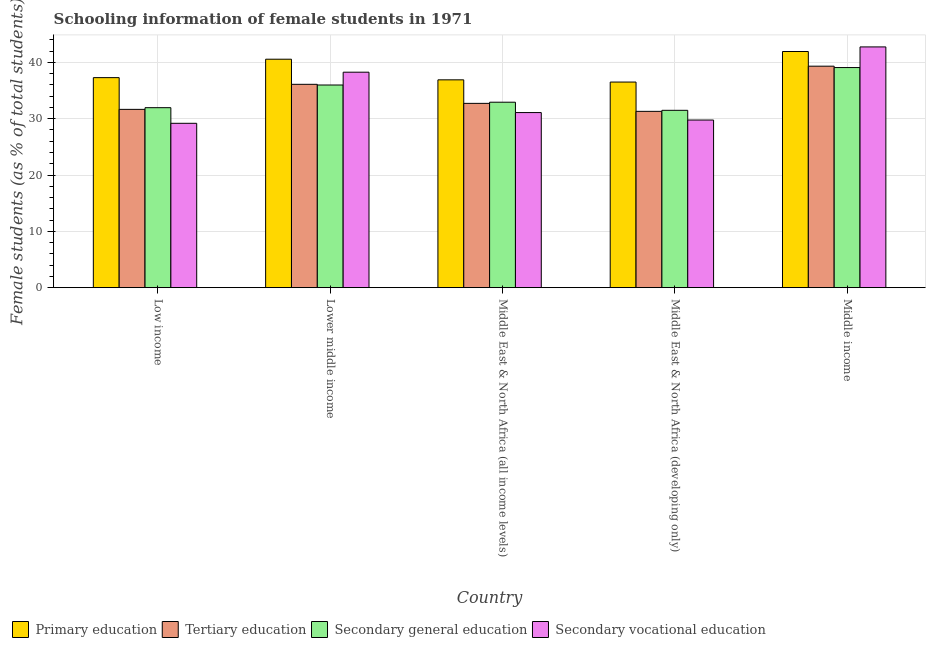How many different coloured bars are there?
Provide a succinct answer. 4. How many groups of bars are there?
Your answer should be compact. 5. How many bars are there on the 1st tick from the left?
Offer a very short reply. 4. What is the label of the 4th group of bars from the left?
Your answer should be compact. Middle East & North Africa (developing only). In how many cases, is the number of bars for a given country not equal to the number of legend labels?
Provide a succinct answer. 0. What is the percentage of female students in primary education in Low income?
Ensure brevity in your answer.  37.3. Across all countries, what is the maximum percentage of female students in tertiary education?
Your response must be concise. 39.33. Across all countries, what is the minimum percentage of female students in primary education?
Keep it short and to the point. 36.51. In which country was the percentage of female students in tertiary education minimum?
Ensure brevity in your answer.  Middle East & North Africa (developing only). What is the total percentage of female students in secondary vocational education in the graph?
Your answer should be very brief. 171.05. What is the difference between the percentage of female students in secondary vocational education in Low income and that in Middle East & North Africa (developing only)?
Provide a short and direct response. -0.58. What is the difference between the percentage of female students in tertiary education in Low income and the percentage of female students in secondary education in Middle income?
Your response must be concise. -7.42. What is the average percentage of female students in secondary education per country?
Provide a short and direct response. 34.29. What is the difference between the percentage of female students in secondary vocational education and percentage of female students in primary education in Lower middle income?
Keep it short and to the point. -2.31. In how many countries, is the percentage of female students in primary education greater than 40 %?
Provide a short and direct response. 2. What is the ratio of the percentage of female students in primary education in Lower middle income to that in Middle East & North Africa (developing only)?
Keep it short and to the point. 1.11. What is the difference between the highest and the second highest percentage of female students in secondary vocational education?
Make the answer very short. 4.49. What is the difference between the highest and the lowest percentage of female students in tertiary education?
Offer a very short reply. 8.02. In how many countries, is the percentage of female students in primary education greater than the average percentage of female students in primary education taken over all countries?
Make the answer very short. 2. Is the sum of the percentage of female students in primary education in Low income and Middle East & North Africa (all income levels) greater than the maximum percentage of female students in secondary education across all countries?
Your answer should be compact. Yes. What does the 4th bar from the left in Middle East & North Africa (developing only) represents?
Your answer should be very brief. Secondary vocational education. What does the 2nd bar from the right in Middle East & North Africa (developing only) represents?
Give a very brief answer. Secondary general education. Are the values on the major ticks of Y-axis written in scientific E-notation?
Your response must be concise. No. Does the graph contain any zero values?
Provide a short and direct response. No. Does the graph contain grids?
Offer a very short reply. Yes. Where does the legend appear in the graph?
Keep it short and to the point. Bottom left. How many legend labels are there?
Give a very brief answer. 4. What is the title of the graph?
Make the answer very short. Schooling information of female students in 1971. Does "Financial sector" appear as one of the legend labels in the graph?
Keep it short and to the point. No. What is the label or title of the X-axis?
Provide a succinct answer. Country. What is the label or title of the Y-axis?
Make the answer very short. Female students (as % of total students). What is the Female students (as % of total students) of Primary education in Low income?
Offer a very short reply. 37.3. What is the Female students (as % of total students) of Tertiary education in Low income?
Provide a succinct answer. 31.66. What is the Female students (as % of total students) of Secondary general education in Low income?
Keep it short and to the point. 31.96. What is the Female students (as % of total students) in Secondary vocational education in Low income?
Keep it short and to the point. 29.18. What is the Female students (as % of total students) in Primary education in Lower middle income?
Offer a very short reply. 40.57. What is the Female students (as % of total students) of Tertiary education in Lower middle income?
Provide a short and direct response. 36.11. What is the Female students (as % of total students) of Secondary general education in Lower middle income?
Your answer should be compact. 35.99. What is the Female students (as % of total students) in Secondary vocational education in Lower middle income?
Your answer should be compact. 38.26. What is the Female students (as % of total students) of Primary education in Middle East & North Africa (all income levels)?
Your response must be concise. 36.9. What is the Female students (as % of total students) of Tertiary education in Middle East & North Africa (all income levels)?
Keep it short and to the point. 32.73. What is the Female students (as % of total students) in Secondary general education in Middle East & North Africa (all income levels)?
Provide a succinct answer. 32.93. What is the Female students (as % of total students) of Secondary vocational education in Middle East & North Africa (all income levels)?
Ensure brevity in your answer.  31.09. What is the Female students (as % of total students) of Primary education in Middle East & North Africa (developing only)?
Provide a succinct answer. 36.51. What is the Female students (as % of total students) of Tertiary education in Middle East & North Africa (developing only)?
Provide a succinct answer. 31.31. What is the Female students (as % of total students) of Secondary general education in Middle East & North Africa (developing only)?
Your response must be concise. 31.49. What is the Female students (as % of total students) of Secondary vocational education in Middle East & North Africa (developing only)?
Offer a terse response. 29.76. What is the Female students (as % of total students) of Primary education in Middle income?
Make the answer very short. 41.93. What is the Female students (as % of total students) of Tertiary education in Middle income?
Keep it short and to the point. 39.33. What is the Female students (as % of total students) of Secondary general education in Middle income?
Your response must be concise. 39.08. What is the Female students (as % of total students) of Secondary vocational education in Middle income?
Make the answer very short. 42.75. Across all countries, what is the maximum Female students (as % of total students) in Primary education?
Ensure brevity in your answer.  41.93. Across all countries, what is the maximum Female students (as % of total students) of Tertiary education?
Provide a succinct answer. 39.33. Across all countries, what is the maximum Female students (as % of total students) of Secondary general education?
Make the answer very short. 39.08. Across all countries, what is the maximum Female students (as % of total students) in Secondary vocational education?
Keep it short and to the point. 42.75. Across all countries, what is the minimum Female students (as % of total students) of Primary education?
Your response must be concise. 36.51. Across all countries, what is the minimum Female students (as % of total students) of Tertiary education?
Provide a short and direct response. 31.31. Across all countries, what is the minimum Female students (as % of total students) of Secondary general education?
Make the answer very short. 31.49. Across all countries, what is the minimum Female students (as % of total students) in Secondary vocational education?
Offer a very short reply. 29.18. What is the total Female students (as % of total students) of Primary education in the graph?
Offer a terse response. 193.21. What is the total Female students (as % of total students) of Tertiary education in the graph?
Ensure brevity in your answer.  171.13. What is the total Female students (as % of total students) in Secondary general education in the graph?
Offer a very short reply. 171.46. What is the total Female students (as % of total students) in Secondary vocational education in the graph?
Give a very brief answer. 171.05. What is the difference between the Female students (as % of total students) in Primary education in Low income and that in Lower middle income?
Keep it short and to the point. -3.27. What is the difference between the Female students (as % of total students) in Tertiary education in Low income and that in Lower middle income?
Offer a very short reply. -4.45. What is the difference between the Female students (as % of total students) in Secondary general education in Low income and that in Lower middle income?
Your answer should be compact. -4.03. What is the difference between the Female students (as % of total students) of Secondary vocational education in Low income and that in Lower middle income?
Your answer should be very brief. -9.08. What is the difference between the Female students (as % of total students) of Primary education in Low income and that in Middle East & North Africa (all income levels)?
Ensure brevity in your answer.  0.39. What is the difference between the Female students (as % of total students) of Tertiary education in Low income and that in Middle East & North Africa (all income levels)?
Provide a short and direct response. -1.07. What is the difference between the Female students (as % of total students) of Secondary general education in Low income and that in Middle East & North Africa (all income levels)?
Keep it short and to the point. -0.97. What is the difference between the Female students (as % of total students) of Secondary vocational education in Low income and that in Middle East & North Africa (all income levels)?
Ensure brevity in your answer.  -1.91. What is the difference between the Female students (as % of total students) of Primary education in Low income and that in Middle East & North Africa (developing only)?
Provide a succinct answer. 0.78. What is the difference between the Female students (as % of total students) in Tertiary education in Low income and that in Middle East & North Africa (developing only)?
Keep it short and to the point. 0.35. What is the difference between the Female students (as % of total students) of Secondary general education in Low income and that in Middle East & North Africa (developing only)?
Make the answer very short. 0.47. What is the difference between the Female students (as % of total students) of Secondary vocational education in Low income and that in Middle East & North Africa (developing only)?
Your response must be concise. -0.58. What is the difference between the Female students (as % of total students) of Primary education in Low income and that in Middle income?
Your answer should be very brief. -4.64. What is the difference between the Female students (as % of total students) in Tertiary education in Low income and that in Middle income?
Your answer should be compact. -7.67. What is the difference between the Female students (as % of total students) of Secondary general education in Low income and that in Middle income?
Your answer should be compact. -7.12. What is the difference between the Female students (as % of total students) in Secondary vocational education in Low income and that in Middle income?
Your answer should be compact. -13.57. What is the difference between the Female students (as % of total students) in Primary education in Lower middle income and that in Middle East & North Africa (all income levels)?
Provide a short and direct response. 3.66. What is the difference between the Female students (as % of total students) of Tertiary education in Lower middle income and that in Middle East & North Africa (all income levels)?
Provide a succinct answer. 3.38. What is the difference between the Female students (as % of total students) of Secondary general education in Lower middle income and that in Middle East & North Africa (all income levels)?
Ensure brevity in your answer.  3.05. What is the difference between the Female students (as % of total students) of Secondary vocational education in Lower middle income and that in Middle East & North Africa (all income levels)?
Keep it short and to the point. 7.17. What is the difference between the Female students (as % of total students) in Primary education in Lower middle income and that in Middle East & North Africa (developing only)?
Provide a short and direct response. 4.06. What is the difference between the Female students (as % of total students) of Tertiary education in Lower middle income and that in Middle East & North Africa (developing only)?
Give a very brief answer. 4.8. What is the difference between the Female students (as % of total students) of Secondary general education in Lower middle income and that in Middle East & North Africa (developing only)?
Make the answer very short. 4.5. What is the difference between the Female students (as % of total students) of Secondary vocational education in Lower middle income and that in Middle East & North Africa (developing only)?
Provide a succinct answer. 8.49. What is the difference between the Female students (as % of total students) in Primary education in Lower middle income and that in Middle income?
Give a very brief answer. -1.37. What is the difference between the Female students (as % of total students) of Tertiary education in Lower middle income and that in Middle income?
Your answer should be very brief. -3.22. What is the difference between the Female students (as % of total students) of Secondary general education in Lower middle income and that in Middle income?
Provide a short and direct response. -3.1. What is the difference between the Female students (as % of total students) of Secondary vocational education in Lower middle income and that in Middle income?
Offer a very short reply. -4.49. What is the difference between the Female students (as % of total students) of Primary education in Middle East & North Africa (all income levels) and that in Middle East & North Africa (developing only)?
Give a very brief answer. 0.39. What is the difference between the Female students (as % of total students) of Tertiary education in Middle East & North Africa (all income levels) and that in Middle East & North Africa (developing only)?
Ensure brevity in your answer.  1.42. What is the difference between the Female students (as % of total students) in Secondary general education in Middle East & North Africa (all income levels) and that in Middle East & North Africa (developing only)?
Keep it short and to the point. 1.44. What is the difference between the Female students (as % of total students) in Secondary vocational education in Middle East & North Africa (all income levels) and that in Middle East & North Africa (developing only)?
Give a very brief answer. 1.33. What is the difference between the Female students (as % of total students) of Primary education in Middle East & North Africa (all income levels) and that in Middle income?
Your response must be concise. -5.03. What is the difference between the Female students (as % of total students) of Tertiary education in Middle East & North Africa (all income levels) and that in Middle income?
Provide a short and direct response. -6.6. What is the difference between the Female students (as % of total students) of Secondary general education in Middle East & North Africa (all income levels) and that in Middle income?
Your answer should be very brief. -6.15. What is the difference between the Female students (as % of total students) in Secondary vocational education in Middle East & North Africa (all income levels) and that in Middle income?
Ensure brevity in your answer.  -11.66. What is the difference between the Female students (as % of total students) of Primary education in Middle East & North Africa (developing only) and that in Middle income?
Provide a short and direct response. -5.42. What is the difference between the Female students (as % of total students) in Tertiary education in Middle East & North Africa (developing only) and that in Middle income?
Your response must be concise. -8.02. What is the difference between the Female students (as % of total students) of Secondary general education in Middle East & North Africa (developing only) and that in Middle income?
Give a very brief answer. -7.59. What is the difference between the Female students (as % of total students) in Secondary vocational education in Middle East & North Africa (developing only) and that in Middle income?
Your response must be concise. -12.99. What is the difference between the Female students (as % of total students) in Primary education in Low income and the Female students (as % of total students) in Tertiary education in Lower middle income?
Your answer should be very brief. 1.19. What is the difference between the Female students (as % of total students) of Primary education in Low income and the Female students (as % of total students) of Secondary general education in Lower middle income?
Your answer should be compact. 1.31. What is the difference between the Female students (as % of total students) in Primary education in Low income and the Female students (as % of total students) in Secondary vocational education in Lower middle income?
Give a very brief answer. -0.96. What is the difference between the Female students (as % of total students) of Tertiary education in Low income and the Female students (as % of total students) of Secondary general education in Lower middle income?
Offer a terse response. -4.33. What is the difference between the Female students (as % of total students) of Tertiary education in Low income and the Female students (as % of total students) of Secondary vocational education in Lower middle income?
Keep it short and to the point. -6.6. What is the difference between the Female students (as % of total students) of Secondary general education in Low income and the Female students (as % of total students) of Secondary vocational education in Lower middle income?
Your answer should be compact. -6.3. What is the difference between the Female students (as % of total students) of Primary education in Low income and the Female students (as % of total students) of Tertiary education in Middle East & North Africa (all income levels)?
Give a very brief answer. 4.57. What is the difference between the Female students (as % of total students) in Primary education in Low income and the Female students (as % of total students) in Secondary general education in Middle East & North Africa (all income levels)?
Ensure brevity in your answer.  4.36. What is the difference between the Female students (as % of total students) of Primary education in Low income and the Female students (as % of total students) of Secondary vocational education in Middle East & North Africa (all income levels)?
Provide a succinct answer. 6.2. What is the difference between the Female students (as % of total students) in Tertiary education in Low income and the Female students (as % of total students) in Secondary general education in Middle East & North Africa (all income levels)?
Offer a very short reply. -1.27. What is the difference between the Female students (as % of total students) of Tertiary education in Low income and the Female students (as % of total students) of Secondary vocational education in Middle East & North Africa (all income levels)?
Provide a succinct answer. 0.57. What is the difference between the Female students (as % of total students) in Secondary general education in Low income and the Female students (as % of total students) in Secondary vocational education in Middle East & North Africa (all income levels)?
Offer a terse response. 0.87. What is the difference between the Female students (as % of total students) of Primary education in Low income and the Female students (as % of total students) of Tertiary education in Middle East & North Africa (developing only)?
Your response must be concise. 5.99. What is the difference between the Female students (as % of total students) in Primary education in Low income and the Female students (as % of total students) in Secondary general education in Middle East & North Africa (developing only)?
Keep it short and to the point. 5.8. What is the difference between the Female students (as % of total students) of Primary education in Low income and the Female students (as % of total students) of Secondary vocational education in Middle East & North Africa (developing only)?
Your answer should be very brief. 7.53. What is the difference between the Female students (as % of total students) of Tertiary education in Low income and the Female students (as % of total students) of Secondary general education in Middle East & North Africa (developing only)?
Make the answer very short. 0.17. What is the difference between the Female students (as % of total students) in Tertiary education in Low income and the Female students (as % of total students) in Secondary vocational education in Middle East & North Africa (developing only)?
Offer a very short reply. 1.9. What is the difference between the Female students (as % of total students) in Secondary general education in Low income and the Female students (as % of total students) in Secondary vocational education in Middle East & North Africa (developing only)?
Your answer should be compact. 2.2. What is the difference between the Female students (as % of total students) in Primary education in Low income and the Female students (as % of total students) in Tertiary education in Middle income?
Offer a very short reply. -2.03. What is the difference between the Female students (as % of total students) of Primary education in Low income and the Female students (as % of total students) of Secondary general education in Middle income?
Your response must be concise. -1.79. What is the difference between the Female students (as % of total students) of Primary education in Low income and the Female students (as % of total students) of Secondary vocational education in Middle income?
Offer a very short reply. -5.45. What is the difference between the Female students (as % of total students) in Tertiary education in Low income and the Female students (as % of total students) in Secondary general education in Middle income?
Your answer should be compact. -7.42. What is the difference between the Female students (as % of total students) of Tertiary education in Low income and the Female students (as % of total students) of Secondary vocational education in Middle income?
Provide a short and direct response. -11.09. What is the difference between the Female students (as % of total students) in Secondary general education in Low income and the Female students (as % of total students) in Secondary vocational education in Middle income?
Provide a short and direct response. -10.79. What is the difference between the Female students (as % of total students) of Primary education in Lower middle income and the Female students (as % of total students) of Tertiary education in Middle East & North Africa (all income levels)?
Your answer should be compact. 7.84. What is the difference between the Female students (as % of total students) in Primary education in Lower middle income and the Female students (as % of total students) in Secondary general education in Middle East & North Africa (all income levels)?
Give a very brief answer. 7.63. What is the difference between the Female students (as % of total students) in Primary education in Lower middle income and the Female students (as % of total students) in Secondary vocational education in Middle East & North Africa (all income levels)?
Ensure brevity in your answer.  9.47. What is the difference between the Female students (as % of total students) in Tertiary education in Lower middle income and the Female students (as % of total students) in Secondary general education in Middle East & North Africa (all income levels)?
Provide a short and direct response. 3.17. What is the difference between the Female students (as % of total students) of Tertiary education in Lower middle income and the Female students (as % of total students) of Secondary vocational education in Middle East & North Africa (all income levels)?
Ensure brevity in your answer.  5.01. What is the difference between the Female students (as % of total students) in Secondary general education in Lower middle income and the Female students (as % of total students) in Secondary vocational education in Middle East & North Africa (all income levels)?
Ensure brevity in your answer.  4.89. What is the difference between the Female students (as % of total students) of Primary education in Lower middle income and the Female students (as % of total students) of Tertiary education in Middle East & North Africa (developing only)?
Provide a short and direct response. 9.26. What is the difference between the Female students (as % of total students) of Primary education in Lower middle income and the Female students (as % of total students) of Secondary general education in Middle East & North Africa (developing only)?
Provide a short and direct response. 9.07. What is the difference between the Female students (as % of total students) in Primary education in Lower middle income and the Female students (as % of total students) in Secondary vocational education in Middle East & North Africa (developing only)?
Your answer should be compact. 10.8. What is the difference between the Female students (as % of total students) of Tertiary education in Lower middle income and the Female students (as % of total students) of Secondary general education in Middle East & North Africa (developing only)?
Your answer should be compact. 4.61. What is the difference between the Female students (as % of total students) in Tertiary education in Lower middle income and the Female students (as % of total students) in Secondary vocational education in Middle East & North Africa (developing only)?
Your answer should be very brief. 6.34. What is the difference between the Female students (as % of total students) of Secondary general education in Lower middle income and the Female students (as % of total students) of Secondary vocational education in Middle East & North Africa (developing only)?
Your answer should be very brief. 6.22. What is the difference between the Female students (as % of total students) of Primary education in Lower middle income and the Female students (as % of total students) of Tertiary education in Middle income?
Offer a terse response. 1.24. What is the difference between the Female students (as % of total students) of Primary education in Lower middle income and the Female students (as % of total students) of Secondary general education in Middle income?
Offer a terse response. 1.48. What is the difference between the Female students (as % of total students) in Primary education in Lower middle income and the Female students (as % of total students) in Secondary vocational education in Middle income?
Make the answer very short. -2.18. What is the difference between the Female students (as % of total students) of Tertiary education in Lower middle income and the Female students (as % of total students) of Secondary general education in Middle income?
Your answer should be very brief. -2.98. What is the difference between the Female students (as % of total students) in Tertiary education in Lower middle income and the Female students (as % of total students) in Secondary vocational education in Middle income?
Offer a very short reply. -6.64. What is the difference between the Female students (as % of total students) in Secondary general education in Lower middle income and the Female students (as % of total students) in Secondary vocational education in Middle income?
Offer a very short reply. -6.76. What is the difference between the Female students (as % of total students) of Primary education in Middle East & North Africa (all income levels) and the Female students (as % of total students) of Tertiary education in Middle East & North Africa (developing only)?
Ensure brevity in your answer.  5.6. What is the difference between the Female students (as % of total students) of Primary education in Middle East & North Africa (all income levels) and the Female students (as % of total students) of Secondary general education in Middle East & North Africa (developing only)?
Your response must be concise. 5.41. What is the difference between the Female students (as % of total students) in Primary education in Middle East & North Africa (all income levels) and the Female students (as % of total students) in Secondary vocational education in Middle East & North Africa (developing only)?
Keep it short and to the point. 7.14. What is the difference between the Female students (as % of total students) of Tertiary education in Middle East & North Africa (all income levels) and the Female students (as % of total students) of Secondary general education in Middle East & North Africa (developing only)?
Provide a succinct answer. 1.23. What is the difference between the Female students (as % of total students) in Tertiary education in Middle East & North Africa (all income levels) and the Female students (as % of total students) in Secondary vocational education in Middle East & North Africa (developing only)?
Make the answer very short. 2.96. What is the difference between the Female students (as % of total students) of Secondary general education in Middle East & North Africa (all income levels) and the Female students (as % of total students) of Secondary vocational education in Middle East & North Africa (developing only)?
Your response must be concise. 3.17. What is the difference between the Female students (as % of total students) of Primary education in Middle East & North Africa (all income levels) and the Female students (as % of total students) of Tertiary education in Middle income?
Give a very brief answer. -2.42. What is the difference between the Female students (as % of total students) of Primary education in Middle East & North Africa (all income levels) and the Female students (as % of total students) of Secondary general education in Middle income?
Offer a very short reply. -2.18. What is the difference between the Female students (as % of total students) in Primary education in Middle East & North Africa (all income levels) and the Female students (as % of total students) in Secondary vocational education in Middle income?
Make the answer very short. -5.85. What is the difference between the Female students (as % of total students) of Tertiary education in Middle East & North Africa (all income levels) and the Female students (as % of total students) of Secondary general education in Middle income?
Keep it short and to the point. -6.36. What is the difference between the Female students (as % of total students) of Tertiary education in Middle East & North Africa (all income levels) and the Female students (as % of total students) of Secondary vocational education in Middle income?
Provide a succinct answer. -10.02. What is the difference between the Female students (as % of total students) in Secondary general education in Middle East & North Africa (all income levels) and the Female students (as % of total students) in Secondary vocational education in Middle income?
Offer a terse response. -9.82. What is the difference between the Female students (as % of total students) in Primary education in Middle East & North Africa (developing only) and the Female students (as % of total students) in Tertiary education in Middle income?
Your answer should be compact. -2.82. What is the difference between the Female students (as % of total students) of Primary education in Middle East & North Africa (developing only) and the Female students (as % of total students) of Secondary general education in Middle income?
Your answer should be very brief. -2.57. What is the difference between the Female students (as % of total students) in Primary education in Middle East & North Africa (developing only) and the Female students (as % of total students) in Secondary vocational education in Middle income?
Ensure brevity in your answer.  -6.24. What is the difference between the Female students (as % of total students) of Tertiary education in Middle East & North Africa (developing only) and the Female students (as % of total students) of Secondary general education in Middle income?
Ensure brevity in your answer.  -7.78. What is the difference between the Female students (as % of total students) in Tertiary education in Middle East & North Africa (developing only) and the Female students (as % of total students) in Secondary vocational education in Middle income?
Your answer should be very brief. -11.44. What is the difference between the Female students (as % of total students) of Secondary general education in Middle East & North Africa (developing only) and the Female students (as % of total students) of Secondary vocational education in Middle income?
Make the answer very short. -11.26. What is the average Female students (as % of total students) in Primary education per country?
Your answer should be very brief. 38.64. What is the average Female students (as % of total students) in Tertiary education per country?
Offer a terse response. 34.23. What is the average Female students (as % of total students) in Secondary general education per country?
Your response must be concise. 34.29. What is the average Female students (as % of total students) of Secondary vocational education per country?
Keep it short and to the point. 34.21. What is the difference between the Female students (as % of total students) of Primary education and Female students (as % of total students) of Tertiary education in Low income?
Provide a short and direct response. 5.63. What is the difference between the Female students (as % of total students) in Primary education and Female students (as % of total students) in Secondary general education in Low income?
Offer a very short reply. 5.33. What is the difference between the Female students (as % of total students) in Primary education and Female students (as % of total students) in Secondary vocational education in Low income?
Give a very brief answer. 8.11. What is the difference between the Female students (as % of total students) in Tertiary education and Female students (as % of total students) in Secondary general education in Low income?
Give a very brief answer. -0.3. What is the difference between the Female students (as % of total students) of Tertiary education and Female students (as % of total students) of Secondary vocational education in Low income?
Your response must be concise. 2.48. What is the difference between the Female students (as % of total students) in Secondary general education and Female students (as % of total students) in Secondary vocational education in Low income?
Your answer should be very brief. 2.78. What is the difference between the Female students (as % of total students) of Primary education and Female students (as % of total students) of Tertiary education in Lower middle income?
Ensure brevity in your answer.  4.46. What is the difference between the Female students (as % of total students) of Primary education and Female students (as % of total students) of Secondary general education in Lower middle income?
Provide a short and direct response. 4.58. What is the difference between the Female students (as % of total students) in Primary education and Female students (as % of total students) in Secondary vocational education in Lower middle income?
Give a very brief answer. 2.31. What is the difference between the Female students (as % of total students) of Tertiary education and Female students (as % of total students) of Secondary general education in Lower middle income?
Keep it short and to the point. 0.12. What is the difference between the Female students (as % of total students) of Tertiary education and Female students (as % of total students) of Secondary vocational education in Lower middle income?
Offer a terse response. -2.15. What is the difference between the Female students (as % of total students) of Secondary general education and Female students (as % of total students) of Secondary vocational education in Lower middle income?
Your answer should be compact. -2.27. What is the difference between the Female students (as % of total students) of Primary education and Female students (as % of total students) of Tertiary education in Middle East & North Africa (all income levels)?
Keep it short and to the point. 4.18. What is the difference between the Female students (as % of total students) in Primary education and Female students (as % of total students) in Secondary general education in Middle East & North Africa (all income levels)?
Provide a short and direct response. 3.97. What is the difference between the Female students (as % of total students) in Primary education and Female students (as % of total students) in Secondary vocational education in Middle East & North Africa (all income levels)?
Provide a short and direct response. 5.81. What is the difference between the Female students (as % of total students) in Tertiary education and Female students (as % of total students) in Secondary general education in Middle East & North Africa (all income levels)?
Ensure brevity in your answer.  -0.21. What is the difference between the Female students (as % of total students) in Tertiary education and Female students (as % of total students) in Secondary vocational education in Middle East & North Africa (all income levels)?
Give a very brief answer. 1.63. What is the difference between the Female students (as % of total students) of Secondary general education and Female students (as % of total students) of Secondary vocational education in Middle East & North Africa (all income levels)?
Your response must be concise. 1.84. What is the difference between the Female students (as % of total students) in Primary education and Female students (as % of total students) in Tertiary education in Middle East & North Africa (developing only)?
Your answer should be compact. 5.2. What is the difference between the Female students (as % of total students) in Primary education and Female students (as % of total students) in Secondary general education in Middle East & North Africa (developing only)?
Your answer should be compact. 5.02. What is the difference between the Female students (as % of total students) of Primary education and Female students (as % of total students) of Secondary vocational education in Middle East & North Africa (developing only)?
Offer a very short reply. 6.75. What is the difference between the Female students (as % of total students) of Tertiary education and Female students (as % of total students) of Secondary general education in Middle East & North Africa (developing only)?
Offer a very short reply. -0.18. What is the difference between the Female students (as % of total students) of Tertiary education and Female students (as % of total students) of Secondary vocational education in Middle East & North Africa (developing only)?
Your response must be concise. 1.54. What is the difference between the Female students (as % of total students) in Secondary general education and Female students (as % of total students) in Secondary vocational education in Middle East & North Africa (developing only)?
Make the answer very short. 1.73. What is the difference between the Female students (as % of total students) in Primary education and Female students (as % of total students) in Tertiary education in Middle income?
Provide a succinct answer. 2.61. What is the difference between the Female students (as % of total students) in Primary education and Female students (as % of total students) in Secondary general education in Middle income?
Your answer should be compact. 2.85. What is the difference between the Female students (as % of total students) of Primary education and Female students (as % of total students) of Secondary vocational education in Middle income?
Provide a short and direct response. -0.82. What is the difference between the Female students (as % of total students) in Tertiary education and Female students (as % of total students) in Secondary general education in Middle income?
Your answer should be very brief. 0.24. What is the difference between the Female students (as % of total students) of Tertiary education and Female students (as % of total students) of Secondary vocational education in Middle income?
Provide a short and direct response. -3.42. What is the difference between the Female students (as % of total students) of Secondary general education and Female students (as % of total students) of Secondary vocational education in Middle income?
Make the answer very short. -3.67. What is the ratio of the Female students (as % of total students) in Primary education in Low income to that in Lower middle income?
Your response must be concise. 0.92. What is the ratio of the Female students (as % of total students) of Tertiary education in Low income to that in Lower middle income?
Your answer should be compact. 0.88. What is the ratio of the Female students (as % of total students) of Secondary general education in Low income to that in Lower middle income?
Your answer should be very brief. 0.89. What is the ratio of the Female students (as % of total students) in Secondary vocational education in Low income to that in Lower middle income?
Keep it short and to the point. 0.76. What is the ratio of the Female students (as % of total students) of Primary education in Low income to that in Middle East & North Africa (all income levels)?
Offer a very short reply. 1.01. What is the ratio of the Female students (as % of total students) in Tertiary education in Low income to that in Middle East & North Africa (all income levels)?
Keep it short and to the point. 0.97. What is the ratio of the Female students (as % of total students) in Secondary general education in Low income to that in Middle East & North Africa (all income levels)?
Provide a succinct answer. 0.97. What is the ratio of the Female students (as % of total students) of Secondary vocational education in Low income to that in Middle East & North Africa (all income levels)?
Your response must be concise. 0.94. What is the ratio of the Female students (as % of total students) of Primary education in Low income to that in Middle East & North Africa (developing only)?
Offer a very short reply. 1.02. What is the ratio of the Female students (as % of total students) of Tertiary education in Low income to that in Middle East & North Africa (developing only)?
Make the answer very short. 1.01. What is the ratio of the Female students (as % of total students) of Secondary general education in Low income to that in Middle East & North Africa (developing only)?
Make the answer very short. 1.01. What is the ratio of the Female students (as % of total students) in Secondary vocational education in Low income to that in Middle East & North Africa (developing only)?
Provide a succinct answer. 0.98. What is the ratio of the Female students (as % of total students) of Primary education in Low income to that in Middle income?
Your answer should be very brief. 0.89. What is the ratio of the Female students (as % of total students) of Tertiary education in Low income to that in Middle income?
Make the answer very short. 0.81. What is the ratio of the Female students (as % of total students) of Secondary general education in Low income to that in Middle income?
Offer a very short reply. 0.82. What is the ratio of the Female students (as % of total students) of Secondary vocational education in Low income to that in Middle income?
Your response must be concise. 0.68. What is the ratio of the Female students (as % of total students) of Primary education in Lower middle income to that in Middle East & North Africa (all income levels)?
Keep it short and to the point. 1.1. What is the ratio of the Female students (as % of total students) of Tertiary education in Lower middle income to that in Middle East & North Africa (all income levels)?
Give a very brief answer. 1.1. What is the ratio of the Female students (as % of total students) of Secondary general education in Lower middle income to that in Middle East & North Africa (all income levels)?
Offer a terse response. 1.09. What is the ratio of the Female students (as % of total students) in Secondary vocational education in Lower middle income to that in Middle East & North Africa (all income levels)?
Provide a short and direct response. 1.23. What is the ratio of the Female students (as % of total students) of Primary education in Lower middle income to that in Middle East & North Africa (developing only)?
Make the answer very short. 1.11. What is the ratio of the Female students (as % of total students) of Tertiary education in Lower middle income to that in Middle East & North Africa (developing only)?
Give a very brief answer. 1.15. What is the ratio of the Female students (as % of total students) in Secondary general education in Lower middle income to that in Middle East & North Africa (developing only)?
Offer a very short reply. 1.14. What is the ratio of the Female students (as % of total students) of Secondary vocational education in Lower middle income to that in Middle East & North Africa (developing only)?
Provide a short and direct response. 1.29. What is the ratio of the Female students (as % of total students) of Primary education in Lower middle income to that in Middle income?
Give a very brief answer. 0.97. What is the ratio of the Female students (as % of total students) of Tertiary education in Lower middle income to that in Middle income?
Keep it short and to the point. 0.92. What is the ratio of the Female students (as % of total students) in Secondary general education in Lower middle income to that in Middle income?
Your answer should be very brief. 0.92. What is the ratio of the Female students (as % of total students) in Secondary vocational education in Lower middle income to that in Middle income?
Provide a succinct answer. 0.9. What is the ratio of the Female students (as % of total students) of Primary education in Middle East & North Africa (all income levels) to that in Middle East & North Africa (developing only)?
Keep it short and to the point. 1.01. What is the ratio of the Female students (as % of total students) of Tertiary education in Middle East & North Africa (all income levels) to that in Middle East & North Africa (developing only)?
Your answer should be compact. 1.05. What is the ratio of the Female students (as % of total students) in Secondary general education in Middle East & North Africa (all income levels) to that in Middle East & North Africa (developing only)?
Provide a succinct answer. 1.05. What is the ratio of the Female students (as % of total students) of Secondary vocational education in Middle East & North Africa (all income levels) to that in Middle East & North Africa (developing only)?
Your answer should be compact. 1.04. What is the ratio of the Female students (as % of total students) in Tertiary education in Middle East & North Africa (all income levels) to that in Middle income?
Provide a succinct answer. 0.83. What is the ratio of the Female students (as % of total students) of Secondary general education in Middle East & North Africa (all income levels) to that in Middle income?
Offer a very short reply. 0.84. What is the ratio of the Female students (as % of total students) of Secondary vocational education in Middle East & North Africa (all income levels) to that in Middle income?
Your answer should be very brief. 0.73. What is the ratio of the Female students (as % of total students) in Primary education in Middle East & North Africa (developing only) to that in Middle income?
Your answer should be compact. 0.87. What is the ratio of the Female students (as % of total students) in Tertiary education in Middle East & North Africa (developing only) to that in Middle income?
Make the answer very short. 0.8. What is the ratio of the Female students (as % of total students) in Secondary general education in Middle East & North Africa (developing only) to that in Middle income?
Offer a very short reply. 0.81. What is the ratio of the Female students (as % of total students) of Secondary vocational education in Middle East & North Africa (developing only) to that in Middle income?
Keep it short and to the point. 0.7. What is the difference between the highest and the second highest Female students (as % of total students) in Primary education?
Provide a short and direct response. 1.37. What is the difference between the highest and the second highest Female students (as % of total students) of Tertiary education?
Offer a very short reply. 3.22. What is the difference between the highest and the second highest Female students (as % of total students) in Secondary general education?
Your response must be concise. 3.1. What is the difference between the highest and the second highest Female students (as % of total students) in Secondary vocational education?
Your response must be concise. 4.49. What is the difference between the highest and the lowest Female students (as % of total students) in Primary education?
Give a very brief answer. 5.42. What is the difference between the highest and the lowest Female students (as % of total students) in Tertiary education?
Provide a succinct answer. 8.02. What is the difference between the highest and the lowest Female students (as % of total students) of Secondary general education?
Give a very brief answer. 7.59. What is the difference between the highest and the lowest Female students (as % of total students) in Secondary vocational education?
Keep it short and to the point. 13.57. 